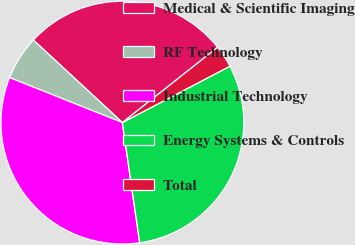<chart> <loc_0><loc_0><loc_500><loc_500><pie_chart><fcel>Medical & Scientific Imaging<fcel>RF Technology<fcel>Industrial Technology<fcel>Energy Systems & Controls<fcel>Total<nl><fcel>27.46%<fcel>5.86%<fcel>33.32%<fcel>30.41%<fcel>2.96%<nl></chart> 